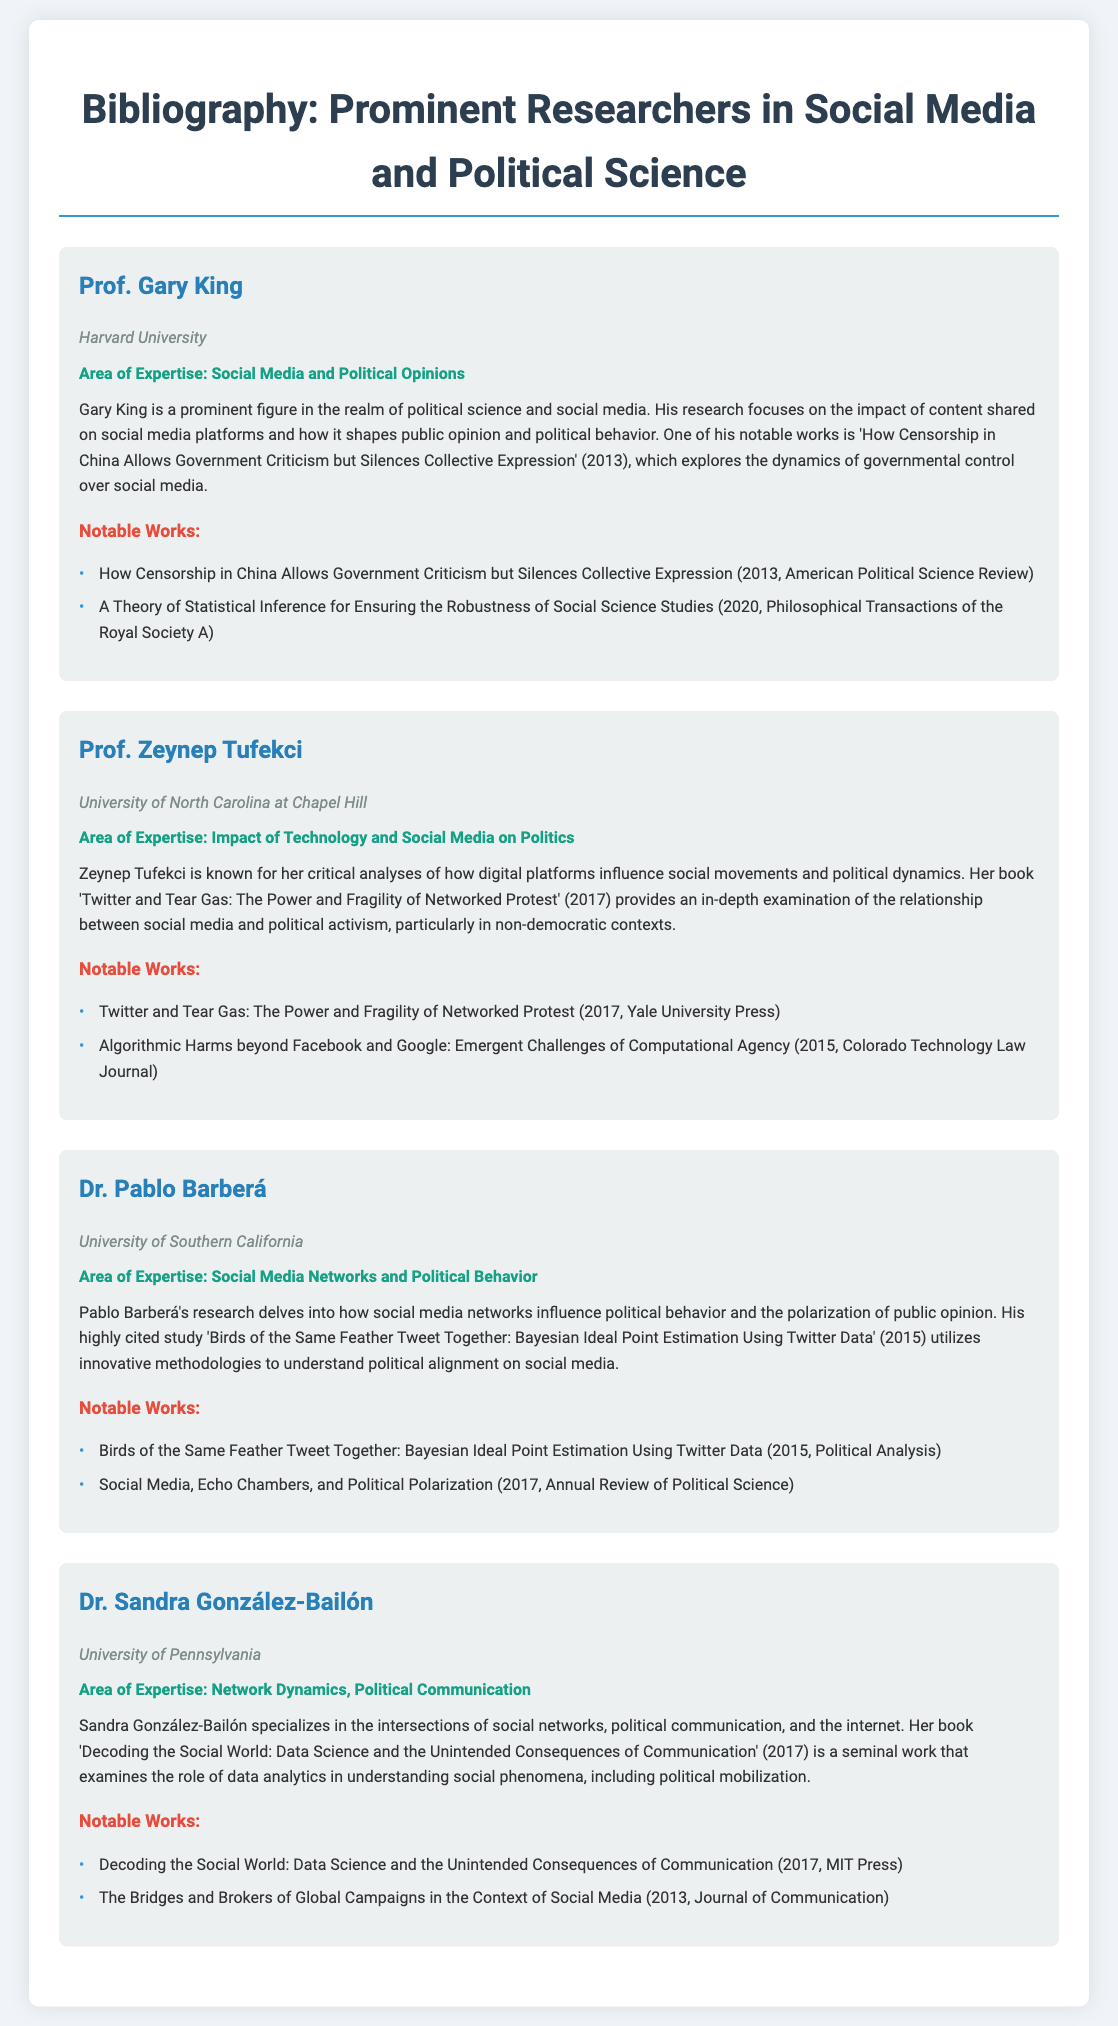What is the affiliation of Prof. Gary King? The document states that Prof. Gary King is affiliated with Harvard University.
Answer: Harvard University What year was "Twitter and Tear Gas" published? The document lists the publication year of "Twitter and Tear Gas" as 2017.
Answer: 2017 Who specializes in network dynamics and political communication? According to the document, Dr. Sandra González-Bailón specializes in network dynamics and political communication.
Answer: Dr. Sandra González-Bailón Which scholar's work focuses on social media networks and political behavior? The document indicates that Dr. Pablo Barberá's research focuses on social media networks and political behavior.
Answer: Dr. Pablo Barberá How many notable works does Zeynep Tufekci have listed in the document? The document lists two notable works for Zeynep Tufekci, which are under the notable works section.
Answer: 2 What is the title of Gary King's notable work that discusses censorship in China? The document describes the title as "How Censorship in China Allows Government Criticism but Silences Collective Expression."
Answer: How Censorship in China Allows Government Criticism but Silences Collective Expression Which university is Dr. Pablo Barberá affiliated with? The document states that Dr. Pablo Barberá is affiliated with the University of Southern California.
Answer: University of Southern California What area of expertise does Zeynep Tufekci have? The document specifies that her area of expertise is the impact of technology and social media on politics.
Answer: Impact of Technology and Social Media on Politics In which year did Dr. Sandra González-Bailón publish her book? The document indicates that Dr. Sandra González-Bailón published her book in 2017.
Answer: 2017 